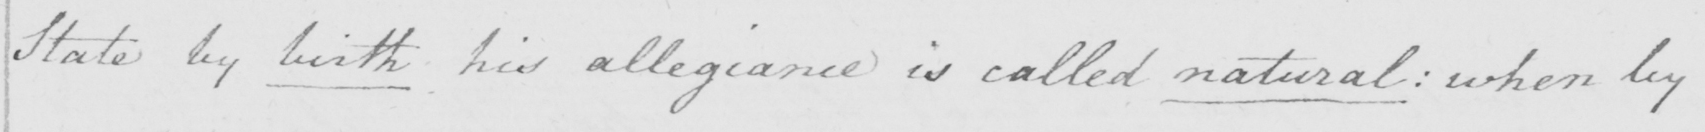Please transcribe the handwritten text in this image. State by birth his allegiance is called natural :  when by 